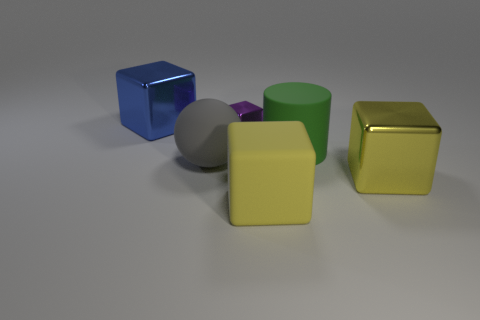Add 3 small purple blocks. How many objects exist? 9 Subtract all yellow rubber cubes. How many cubes are left? 3 Subtract 1 spheres. How many spheres are left? 0 Subtract all purple blocks. Subtract all green balls. How many blocks are left? 3 Subtract all green spheres. How many cyan cubes are left? 0 Subtract all blue metal balls. Subtract all big yellow blocks. How many objects are left? 4 Add 1 big green rubber objects. How many big green rubber objects are left? 2 Add 2 metal things. How many metal things exist? 5 Subtract all blue blocks. How many blocks are left? 3 Subtract 0 red blocks. How many objects are left? 6 